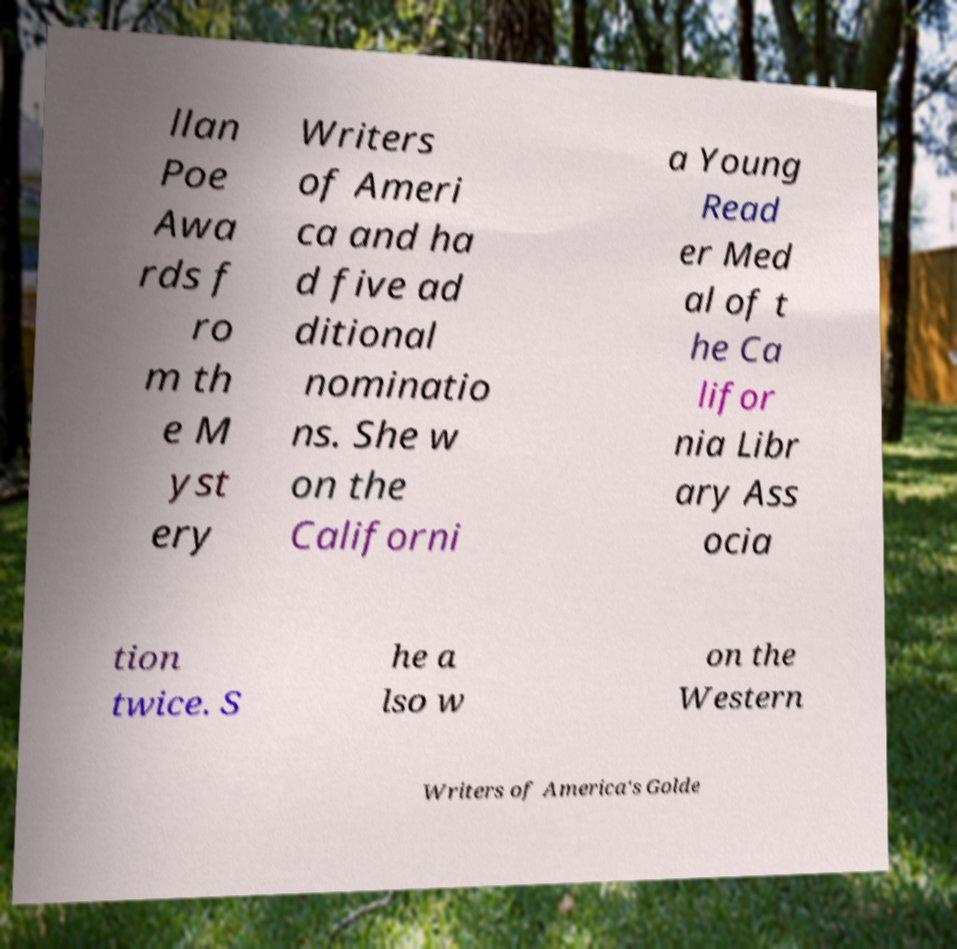For documentation purposes, I need the text within this image transcribed. Could you provide that? llan Poe Awa rds f ro m th e M yst ery Writers of Ameri ca and ha d five ad ditional nominatio ns. She w on the Californi a Young Read er Med al of t he Ca lifor nia Libr ary Ass ocia tion twice. S he a lso w on the Western Writers of America's Golde 